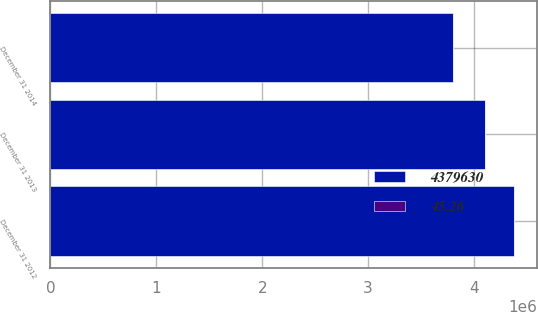Convert chart to OTSL. <chart><loc_0><loc_0><loc_500><loc_500><stacked_bar_chart><ecel><fcel>December 31 2014<fcel>December 31 2013<fcel>December 31 2012<nl><fcel>4.37963e+06<fcel>3.80487e+06<fcel>4.10193e+06<fcel>4.37963e+06<nl><fcel>45.26<fcel>33.86<fcel>40.4<fcel>45.26<nl></chart> 